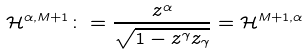Convert formula to latex. <formula><loc_0><loc_0><loc_500><loc_500>\mathcal { H } ^ { \alpha , M + 1 } \colon = \frac { z ^ { \alpha } } { \sqrt { 1 - z ^ { \gamma } z _ { \gamma } } } = \mathcal { H } ^ { M + 1 , \alpha }</formula> 